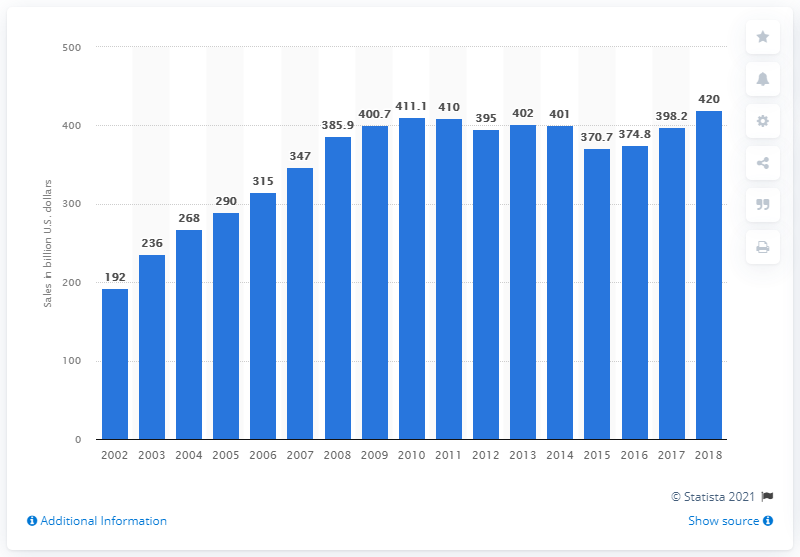Identify some key points in this picture. The total sales of arms and military services by the largest arms-producing companies in 2018 were approximately 420 billion U.S. dollars. The total revenue of the 100 largest arms companies in 2002 was $192 billion. 